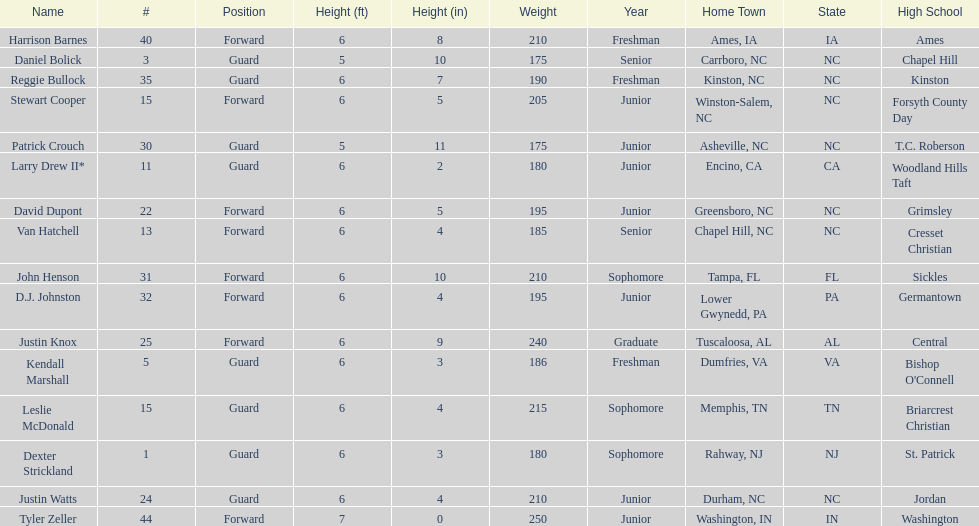Tallest player on the team Tyler Zeller. 